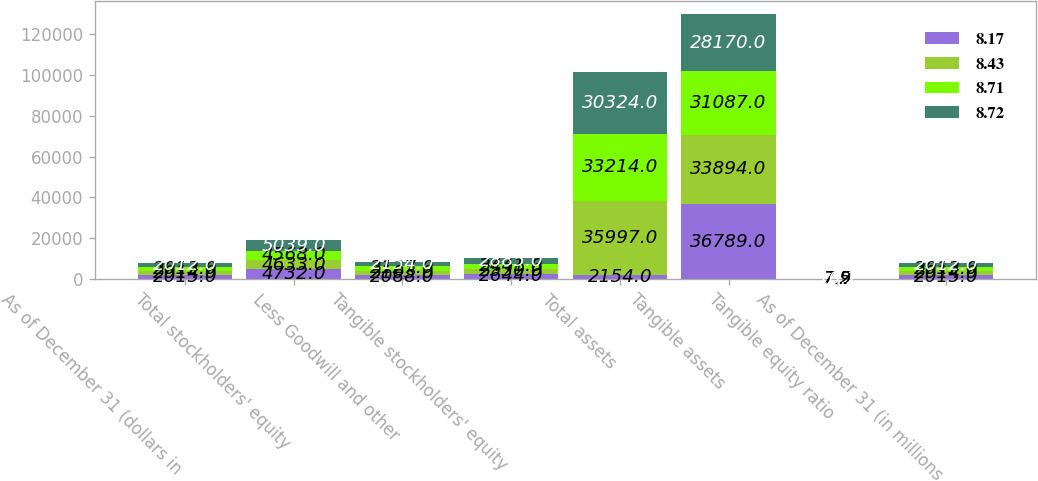Convert chart. <chart><loc_0><loc_0><loc_500><loc_500><stacked_bar_chart><ecel><fcel>As of December 31 (dollars in<fcel>Total stockholders' equity<fcel>Less Goodwill and other<fcel>Tangible stockholders' equity<fcel>Total assets<fcel>Tangible assets<fcel>Tangible equity ratio<fcel>As of December 31 (in millions<nl><fcel>8.17<fcel>2015<fcel>4732<fcel>2088<fcel>2644<fcel>2154<fcel>36789<fcel>7.2<fcel>2015<nl><fcel>8.43<fcel>2014<fcel>4633<fcel>2103<fcel>2530<fcel>35997<fcel>33894<fcel>7.5<fcel>2014<nl><fcel>8.71<fcel>2013<fcel>4568<fcel>2127<fcel>2441<fcel>33214<fcel>31087<fcel>7.9<fcel>2013<nl><fcel>8.72<fcel>2012<fcel>5039<fcel>2154<fcel>2885<fcel>30324<fcel>28170<fcel>10.2<fcel>2012<nl></chart> 